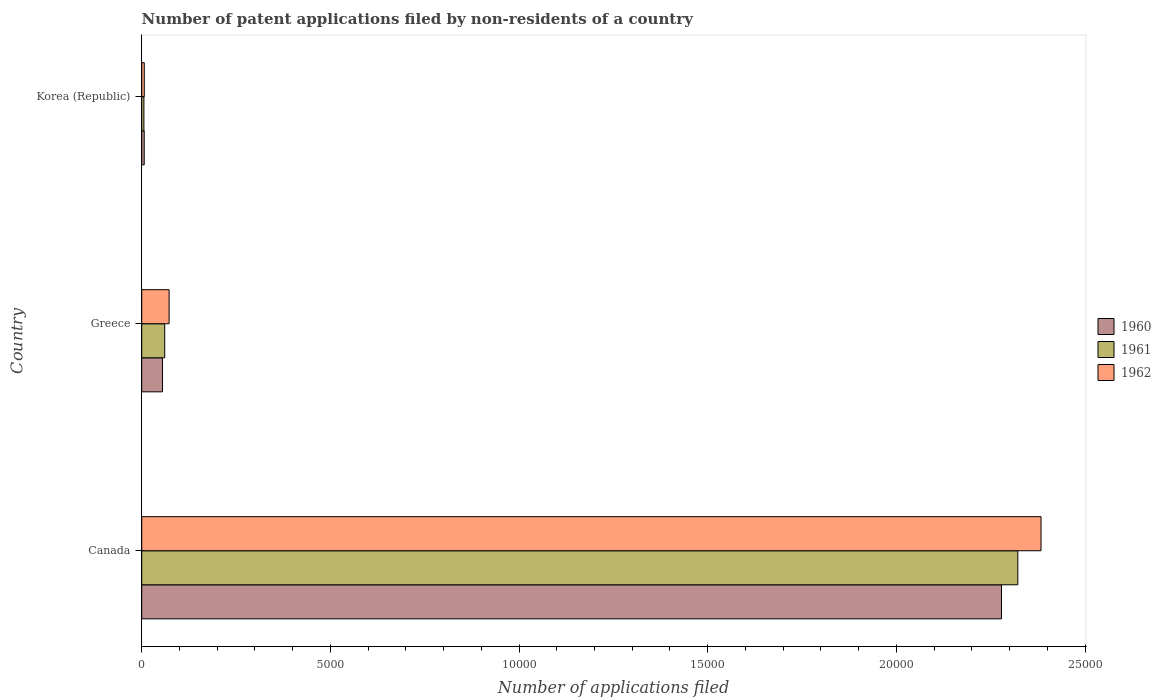How many groups of bars are there?
Your response must be concise. 3. Are the number of bars on each tick of the Y-axis equal?
Offer a very short reply. Yes. In how many cases, is the number of bars for a given country not equal to the number of legend labels?
Your answer should be very brief. 0. What is the number of applications filed in 1960 in Greece?
Ensure brevity in your answer.  551. Across all countries, what is the maximum number of applications filed in 1962?
Your response must be concise. 2.38e+04. Across all countries, what is the minimum number of applications filed in 1961?
Provide a short and direct response. 58. In which country was the number of applications filed in 1960 minimum?
Offer a terse response. Korea (Republic). What is the total number of applications filed in 1961 in the graph?
Your response must be concise. 2.39e+04. What is the difference between the number of applications filed in 1962 in Canada and that in Greece?
Ensure brevity in your answer.  2.31e+04. What is the difference between the number of applications filed in 1960 in Greece and the number of applications filed in 1961 in Canada?
Ensure brevity in your answer.  -2.27e+04. What is the average number of applications filed in 1961 per country?
Give a very brief answer. 7962. What is the ratio of the number of applications filed in 1962 in Canada to that in Greece?
Your answer should be very brief. 32.83. Is the number of applications filed in 1962 in Canada less than that in Greece?
Offer a very short reply. No. What is the difference between the highest and the second highest number of applications filed in 1962?
Your response must be concise. 2.31e+04. What is the difference between the highest and the lowest number of applications filed in 1962?
Make the answer very short. 2.38e+04. In how many countries, is the number of applications filed in 1960 greater than the average number of applications filed in 1960 taken over all countries?
Your answer should be very brief. 1. What does the 3rd bar from the top in Korea (Republic) represents?
Your response must be concise. 1960. Are all the bars in the graph horizontal?
Give a very brief answer. Yes. What is the difference between two consecutive major ticks on the X-axis?
Provide a succinct answer. 5000. What is the title of the graph?
Provide a short and direct response. Number of patent applications filed by non-residents of a country. What is the label or title of the X-axis?
Offer a very short reply. Number of applications filed. What is the label or title of the Y-axis?
Your answer should be very brief. Country. What is the Number of applications filed of 1960 in Canada?
Make the answer very short. 2.28e+04. What is the Number of applications filed in 1961 in Canada?
Keep it short and to the point. 2.32e+04. What is the Number of applications filed in 1962 in Canada?
Make the answer very short. 2.38e+04. What is the Number of applications filed of 1960 in Greece?
Give a very brief answer. 551. What is the Number of applications filed of 1961 in Greece?
Your response must be concise. 609. What is the Number of applications filed in 1962 in Greece?
Provide a succinct answer. 726. What is the Number of applications filed in 1960 in Korea (Republic)?
Keep it short and to the point. 66. What is the Number of applications filed of 1962 in Korea (Republic)?
Your answer should be very brief. 68. Across all countries, what is the maximum Number of applications filed of 1960?
Offer a very short reply. 2.28e+04. Across all countries, what is the maximum Number of applications filed of 1961?
Your response must be concise. 2.32e+04. Across all countries, what is the maximum Number of applications filed of 1962?
Offer a terse response. 2.38e+04. Across all countries, what is the minimum Number of applications filed of 1962?
Provide a succinct answer. 68. What is the total Number of applications filed in 1960 in the graph?
Your response must be concise. 2.34e+04. What is the total Number of applications filed in 1961 in the graph?
Offer a very short reply. 2.39e+04. What is the total Number of applications filed in 1962 in the graph?
Give a very brief answer. 2.46e+04. What is the difference between the Number of applications filed in 1960 in Canada and that in Greece?
Offer a terse response. 2.22e+04. What is the difference between the Number of applications filed in 1961 in Canada and that in Greece?
Offer a terse response. 2.26e+04. What is the difference between the Number of applications filed of 1962 in Canada and that in Greece?
Ensure brevity in your answer.  2.31e+04. What is the difference between the Number of applications filed of 1960 in Canada and that in Korea (Republic)?
Provide a short and direct response. 2.27e+04. What is the difference between the Number of applications filed in 1961 in Canada and that in Korea (Republic)?
Give a very brief answer. 2.32e+04. What is the difference between the Number of applications filed in 1962 in Canada and that in Korea (Republic)?
Provide a succinct answer. 2.38e+04. What is the difference between the Number of applications filed in 1960 in Greece and that in Korea (Republic)?
Your answer should be compact. 485. What is the difference between the Number of applications filed in 1961 in Greece and that in Korea (Republic)?
Give a very brief answer. 551. What is the difference between the Number of applications filed in 1962 in Greece and that in Korea (Republic)?
Your response must be concise. 658. What is the difference between the Number of applications filed in 1960 in Canada and the Number of applications filed in 1961 in Greece?
Give a very brief answer. 2.22e+04. What is the difference between the Number of applications filed in 1960 in Canada and the Number of applications filed in 1962 in Greece?
Offer a very short reply. 2.21e+04. What is the difference between the Number of applications filed of 1961 in Canada and the Number of applications filed of 1962 in Greece?
Give a very brief answer. 2.25e+04. What is the difference between the Number of applications filed in 1960 in Canada and the Number of applications filed in 1961 in Korea (Republic)?
Offer a terse response. 2.27e+04. What is the difference between the Number of applications filed of 1960 in Canada and the Number of applications filed of 1962 in Korea (Republic)?
Your response must be concise. 2.27e+04. What is the difference between the Number of applications filed in 1961 in Canada and the Number of applications filed in 1962 in Korea (Republic)?
Provide a short and direct response. 2.32e+04. What is the difference between the Number of applications filed of 1960 in Greece and the Number of applications filed of 1961 in Korea (Republic)?
Make the answer very short. 493. What is the difference between the Number of applications filed in 1960 in Greece and the Number of applications filed in 1962 in Korea (Republic)?
Keep it short and to the point. 483. What is the difference between the Number of applications filed in 1961 in Greece and the Number of applications filed in 1962 in Korea (Republic)?
Keep it short and to the point. 541. What is the average Number of applications filed of 1960 per country?
Ensure brevity in your answer.  7801. What is the average Number of applications filed in 1961 per country?
Offer a very short reply. 7962. What is the average Number of applications filed in 1962 per country?
Give a very brief answer. 8209.33. What is the difference between the Number of applications filed in 1960 and Number of applications filed in 1961 in Canada?
Your answer should be very brief. -433. What is the difference between the Number of applications filed of 1960 and Number of applications filed of 1962 in Canada?
Your answer should be compact. -1048. What is the difference between the Number of applications filed of 1961 and Number of applications filed of 1962 in Canada?
Provide a short and direct response. -615. What is the difference between the Number of applications filed in 1960 and Number of applications filed in 1961 in Greece?
Provide a short and direct response. -58. What is the difference between the Number of applications filed in 1960 and Number of applications filed in 1962 in Greece?
Provide a short and direct response. -175. What is the difference between the Number of applications filed in 1961 and Number of applications filed in 1962 in Greece?
Provide a short and direct response. -117. What is the difference between the Number of applications filed of 1960 and Number of applications filed of 1961 in Korea (Republic)?
Ensure brevity in your answer.  8. What is the ratio of the Number of applications filed in 1960 in Canada to that in Greece?
Give a very brief answer. 41.35. What is the ratio of the Number of applications filed in 1961 in Canada to that in Greece?
Offer a terse response. 38.13. What is the ratio of the Number of applications filed of 1962 in Canada to that in Greece?
Offer a terse response. 32.83. What is the ratio of the Number of applications filed in 1960 in Canada to that in Korea (Republic)?
Your answer should be very brief. 345.24. What is the ratio of the Number of applications filed of 1961 in Canada to that in Korea (Republic)?
Your answer should be compact. 400.33. What is the ratio of the Number of applications filed in 1962 in Canada to that in Korea (Republic)?
Your answer should be compact. 350.5. What is the ratio of the Number of applications filed of 1960 in Greece to that in Korea (Republic)?
Offer a terse response. 8.35. What is the ratio of the Number of applications filed of 1962 in Greece to that in Korea (Republic)?
Give a very brief answer. 10.68. What is the difference between the highest and the second highest Number of applications filed of 1960?
Provide a succinct answer. 2.22e+04. What is the difference between the highest and the second highest Number of applications filed of 1961?
Your answer should be very brief. 2.26e+04. What is the difference between the highest and the second highest Number of applications filed of 1962?
Offer a very short reply. 2.31e+04. What is the difference between the highest and the lowest Number of applications filed of 1960?
Offer a terse response. 2.27e+04. What is the difference between the highest and the lowest Number of applications filed of 1961?
Keep it short and to the point. 2.32e+04. What is the difference between the highest and the lowest Number of applications filed of 1962?
Your answer should be compact. 2.38e+04. 